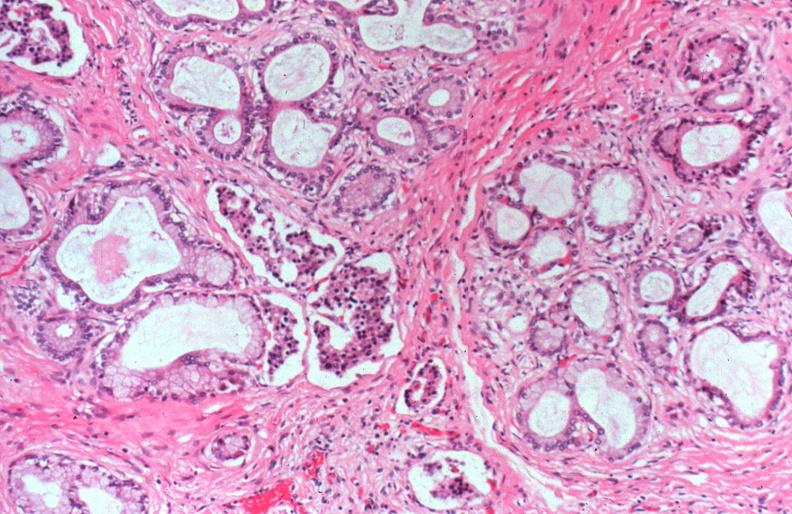what is present?
Answer the question using a single word or phrase. Pancreas 